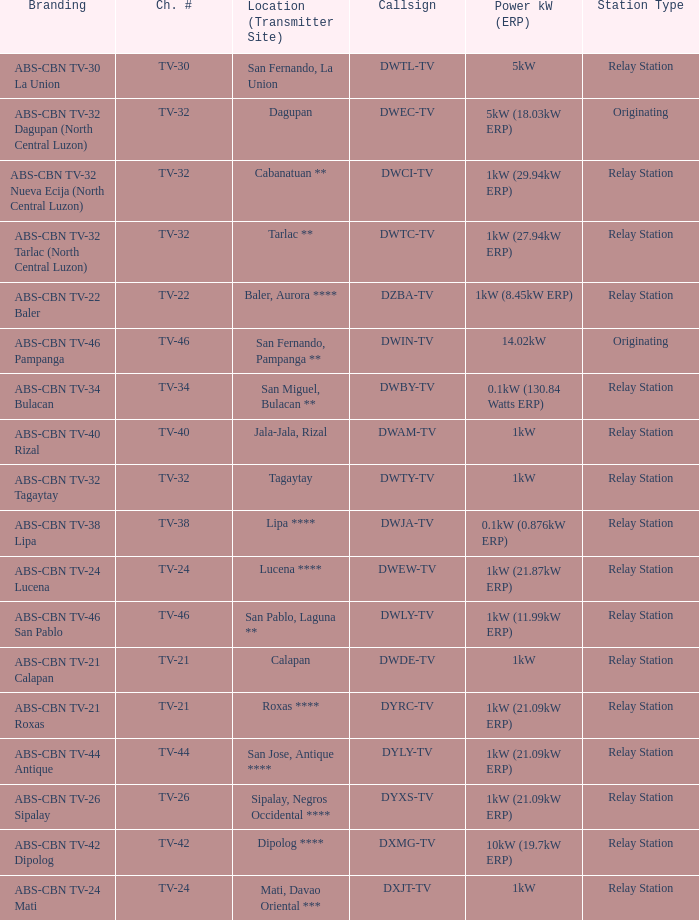The location (transmitter site) San Fernando, Pampanga ** has what Power kW (ERP)? 14.02kW. 